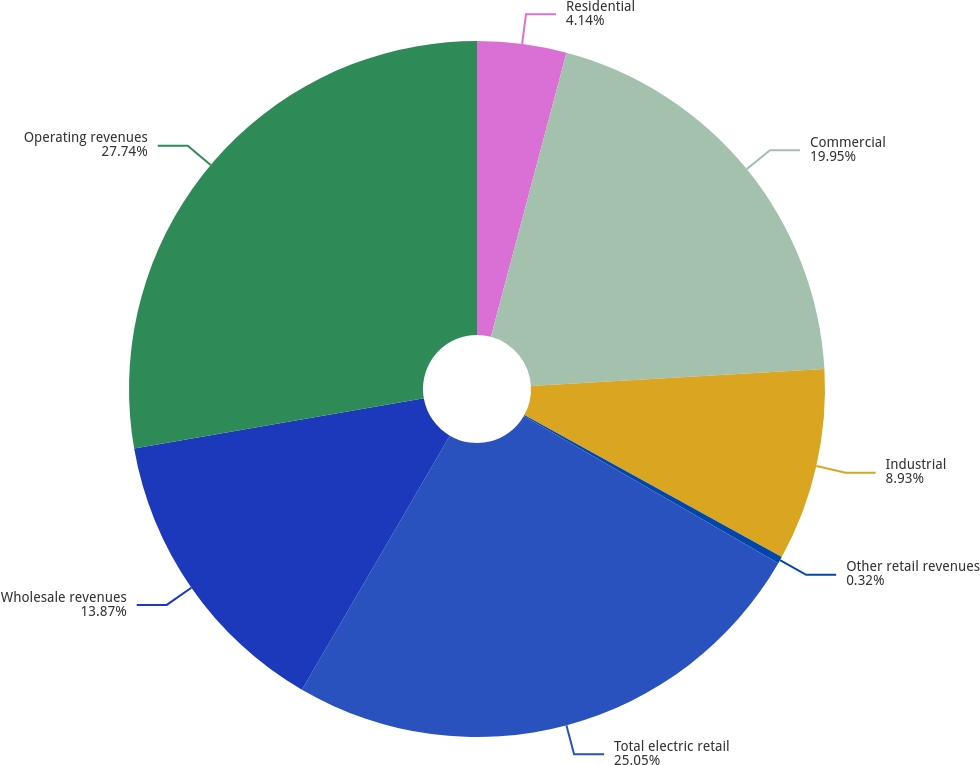Convert chart. <chart><loc_0><loc_0><loc_500><loc_500><pie_chart><fcel>Residential<fcel>Commercial<fcel>Industrial<fcel>Other retail revenues<fcel>Total electric retail<fcel>Wholesale revenues<fcel>Operating revenues<nl><fcel>4.14%<fcel>19.95%<fcel>8.93%<fcel>0.32%<fcel>25.05%<fcel>13.87%<fcel>27.74%<nl></chart> 